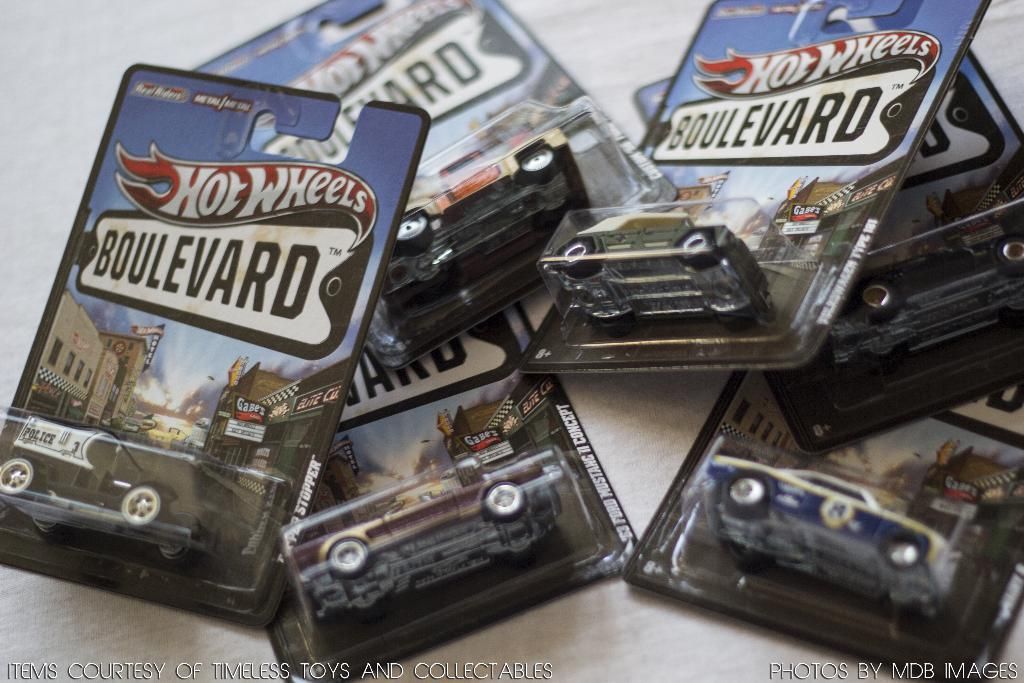What type of toys are present in the image? There are toy cars in the image. How many different colors can be seen among the toy cars? The toy cars are in black, brown, red, green, white, and blue. Are the toy cars individually packaged? Yes, the toy cars are in packets. What is the color of the surface on which the packets are placed? The packets are on a white-colored surface. What type of paste is used to stick the list on the sheet in the image? There is no paste, list, or sheet present in the image; it only features toy cars in packets on a white-colored surface. 